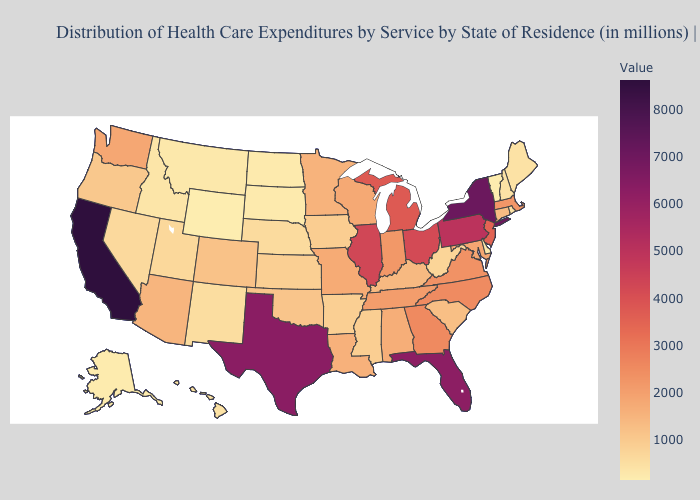Among the states that border Pennsylvania , does Delaware have the highest value?
Concise answer only. No. Is the legend a continuous bar?
Give a very brief answer. Yes. Which states have the lowest value in the USA?
Be succinct. Wyoming. Which states have the lowest value in the USA?
Short answer required. Wyoming. Does Illinois have a higher value than New York?
Answer briefly. No. Which states have the lowest value in the USA?
Concise answer only. Wyoming. Which states hav the highest value in the MidWest?
Give a very brief answer. Illinois. 